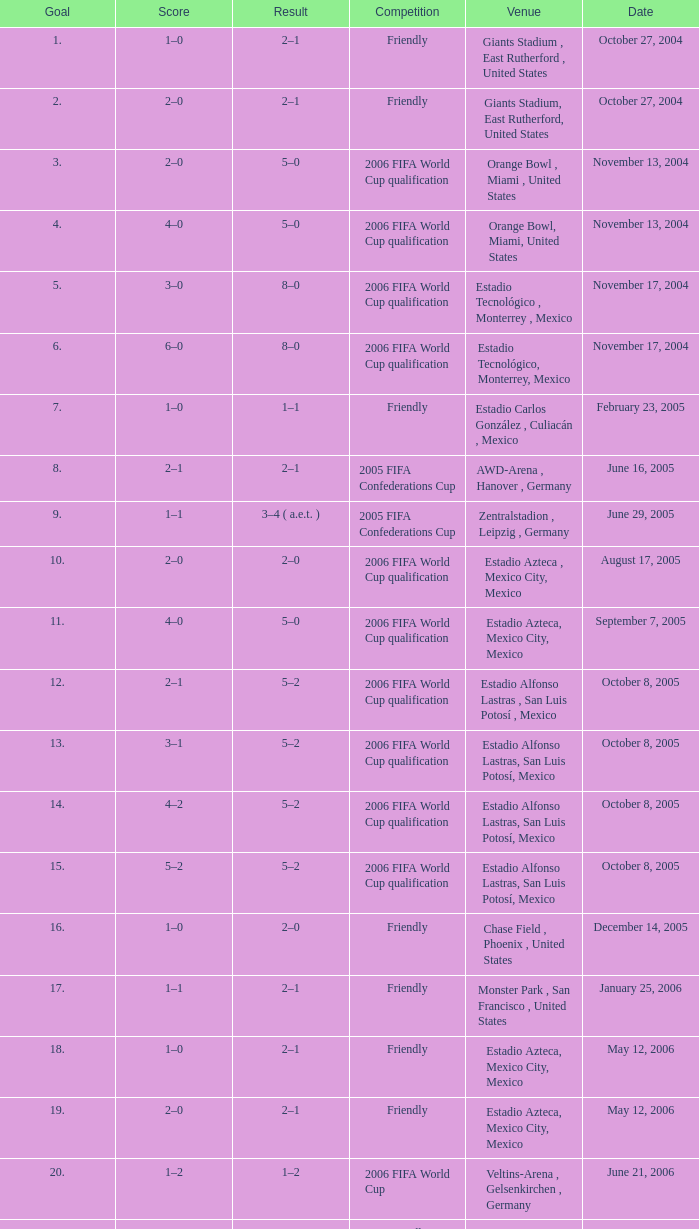Which Score has a Result of 2–1, and a Competition of friendly, and a Goal smaller than 17? 1–0, 2–0. 